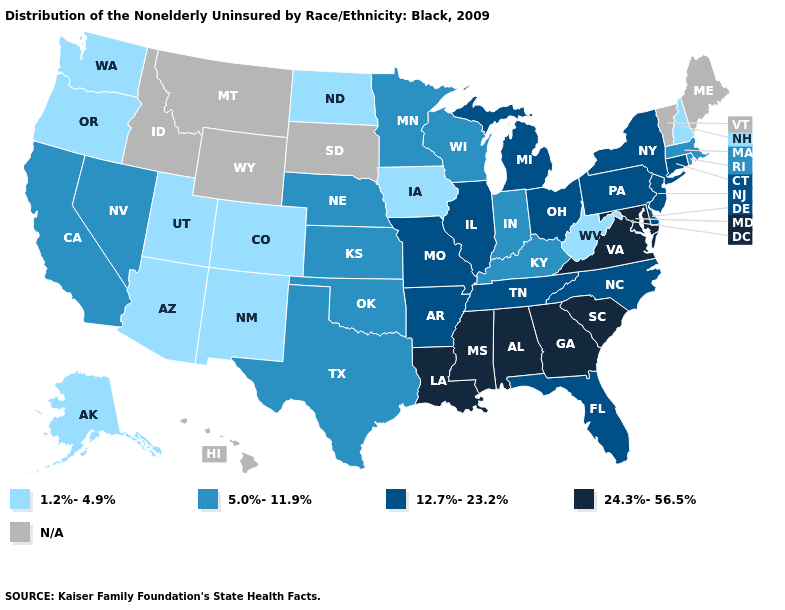Does New Hampshire have the lowest value in the USA?
Quick response, please. Yes. What is the lowest value in the Northeast?
Keep it brief. 1.2%-4.9%. Name the states that have a value in the range 12.7%-23.2%?
Concise answer only. Arkansas, Connecticut, Delaware, Florida, Illinois, Michigan, Missouri, New Jersey, New York, North Carolina, Ohio, Pennsylvania, Tennessee. Name the states that have a value in the range 1.2%-4.9%?
Concise answer only. Alaska, Arizona, Colorado, Iowa, New Hampshire, New Mexico, North Dakota, Oregon, Utah, Washington, West Virginia. Name the states that have a value in the range 5.0%-11.9%?
Give a very brief answer. California, Indiana, Kansas, Kentucky, Massachusetts, Minnesota, Nebraska, Nevada, Oklahoma, Rhode Island, Texas, Wisconsin. What is the highest value in the USA?
Write a very short answer. 24.3%-56.5%. Is the legend a continuous bar?
Quick response, please. No. What is the value of Illinois?
Answer briefly. 12.7%-23.2%. Name the states that have a value in the range 1.2%-4.9%?
Write a very short answer. Alaska, Arizona, Colorado, Iowa, New Hampshire, New Mexico, North Dakota, Oregon, Utah, Washington, West Virginia. Which states have the lowest value in the USA?
Answer briefly. Alaska, Arizona, Colorado, Iowa, New Hampshire, New Mexico, North Dakota, Oregon, Utah, Washington, West Virginia. What is the value of New York?
Answer briefly. 12.7%-23.2%. What is the lowest value in the USA?
Keep it brief. 1.2%-4.9%. What is the value of California?
Short answer required. 5.0%-11.9%. What is the highest value in the MidWest ?
Concise answer only. 12.7%-23.2%. Which states have the lowest value in the Northeast?
Be succinct. New Hampshire. 